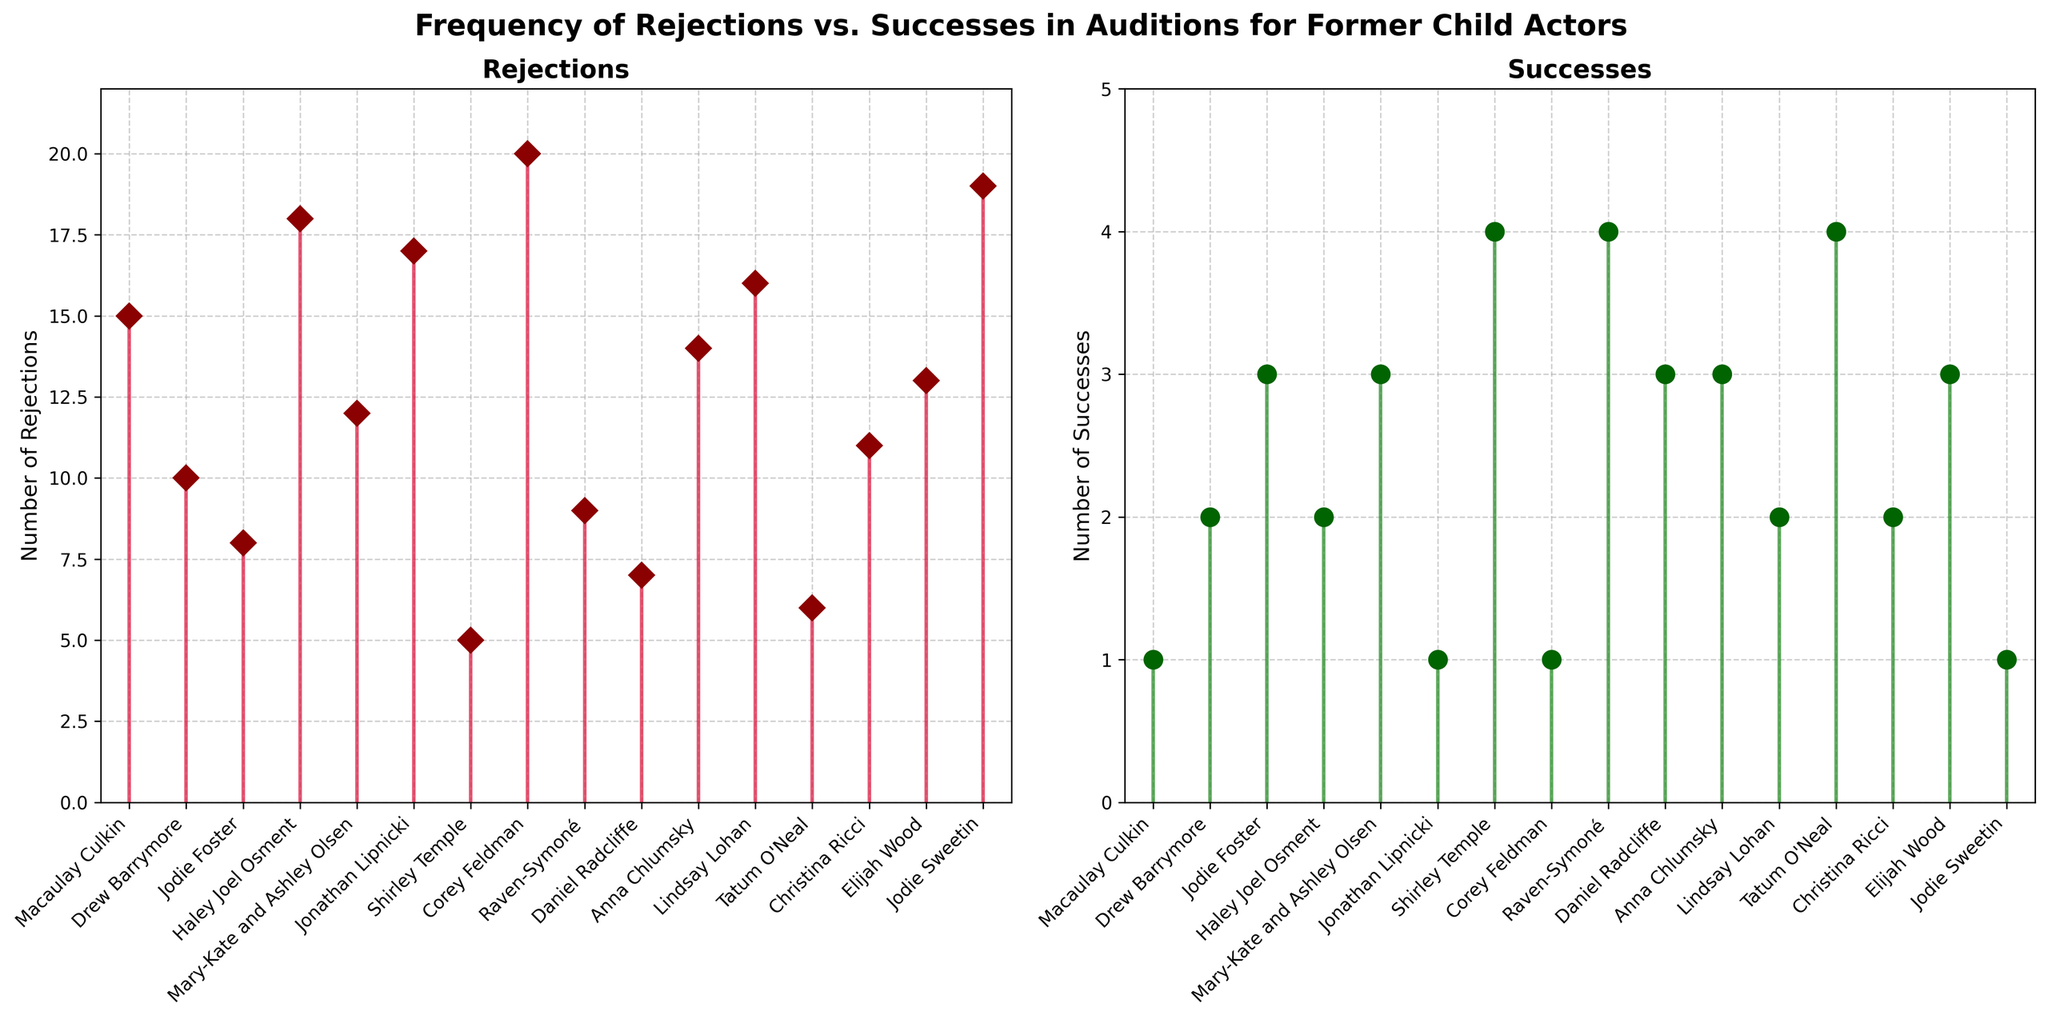What is the title of the figure? The title of the figure is displayed at the top of the plot, in bold and larger font size.
Answer: Frequency of Rejections vs. Successes in Auditions for Former Child Actors Which actor experienced the highest number of rejections? Looking at the first subplot for rejections, identify the actor associated with the highest stem.
Answer: Corey Feldman How many more rejections does Haley Joel Osment have compared to Drew Barrymore? Find the rejections for both actors in the first subplot. Haley Joel Osment has 18 rejections, and Drew Barrymore has 10. Calculate the difference: 18 - 10.
Answer: 8 Which of the two has more successes: Daniel Radcliffe or Elijah Wood? Refer to the second subplot for successes. Count the green stems for Daniel Radcliffe and Elijah Wood. Daniel Radcliffe has 3, and Elijah Wood also has 3.
Answer: Both have 3 What is the average number of successes for all actors? Sum the successes from the second subplot: 1 + 2 + 3 + 2 + 3 + 1 + 4 + 1 + 4 + 3 + 3 + 2 + 4 + 2 + 3 + 1. The total is 39. Divide by the number of actors, which is 16.
Answer: 2.4 How many actors have more than 3 rejections but less than 10 rejections? From the first subplot, count actors with rejections between (and including) these values. Shirley Temple (5), Tatum O'Neal (6), Daniel Radcliffe (7), Jodie Foster (8).
Answer: 4 What colors represent rejections and successes in the plot? Identify the colors of the lines and markers in both subplots. The first subplot for rejections uses shades of red, while the second for successes uses shades of green.
Answer: Red for rejections, green for successes Compare the number of rejections of Jonathan Lipnicki and Jodie Sweetin. Who experienced more? Look at the first subplot for rejections. Jonathan Lipnicki has 17 rejections, and Jodie Sweetin has 19.
Answer: Jodie Sweetin What is the difference in the number of successes between Shirley Temple and Jodie Foster? From the second subplot, Shirley Temple has 4 successes, and Jodie Foster has 3. Calculate the difference: 4 - 3.
Answer: 1 Which actor has equal numbers of rejections and successes? Look at both subplots to find an actor whose rejections and successes match. No actor in the data set has equal numbers.
Answer: None 